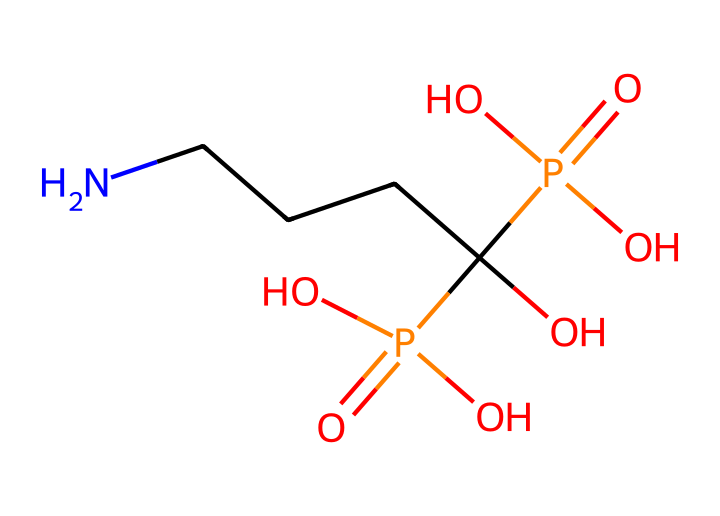What is the name of this medication? The structure corresponds to alendronate, which is used in the treatment and prevention of osteoporosis.
Answer: alendronate How many nitrogen atoms are present in this compound? The SMILES notation indicates a single nitrogen (N) in the structure, which is present at the beginning of the sequence.
Answer: 1 How many hydroxyl (OH) groups are there in this chemical structure? By examining the structure, there are two hydroxyl (OH) groups represented, as indicated by the two (O) components in parentheses connected to a carbon atom.
Answer: 2 What functional group is indicated by the "P(=O)(O)O" notation? This portion of the structure shows the presence of phosphonic acid functional groups, which are characteristic in the structure of this medication for activity in bone metabolism.
Answer: phosphonic acid What is the total number of oxygen atoms in the alendronate structure? Counting from the SMILES: there are four oxygen atoms attached to the phosphonic acid groups and one in the hydroxyl groups, totaling five oxygen atoms overall.
Answer: 5 Which part of alendronate is responsible for its binding to bone? The phosphonate groups in the structure facilitate strong binding to hydroxyapatite in bone tissue, playing a crucial role in its therapeutic action.
Answer: phosphonate groups Why is the nitrogen atom important in this chemical? The nitrogen atom contributes to the structural stability and activity of alendronate, influencing its mechanism in inhibiting bone resorption.
Answer: stability and activity 